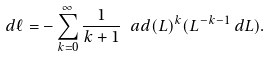<formula> <loc_0><loc_0><loc_500><loc_500>d \ell = - \sum _ { k = 0 } ^ { \infty } \frac { 1 } { k + 1 } \ a d ( L ) ^ { k } ( L ^ { - k - 1 } \, d L ) .</formula> 